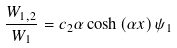<formula> <loc_0><loc_0><loc_500><loc_500>\frac { W _ { 1 , 2 } } { W _ { 1 } } = c _ { 2 } \alpha \cosh \left ( \alpha x \right ) \psi _ { 1 }</formula> 